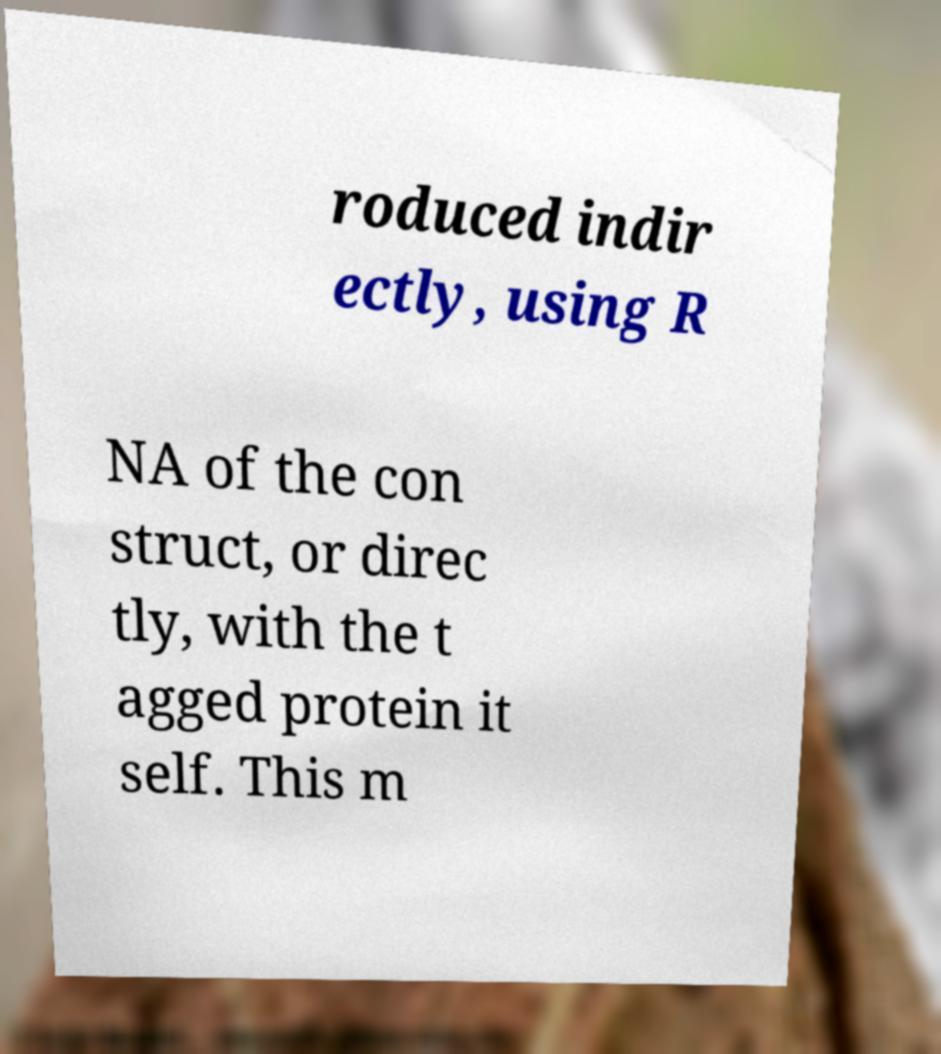Could you assist in decoding the text presented in this image and type it out clearly? roduced indir ectly, using R NA of the con struct, or direc tly, with the t agged protein it self. This m 